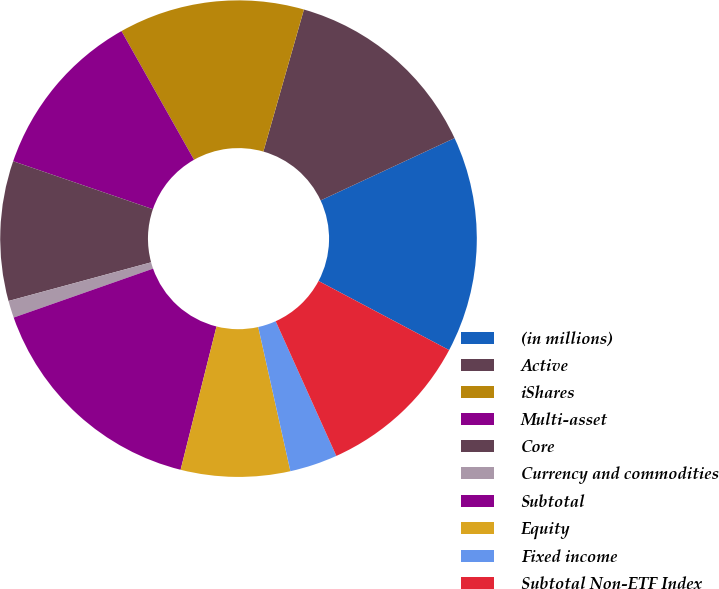Convert chart. <chart><loc_0><loc_0><loc_500><loc_500><pie_chart><fcel>(in millions)<fcel>Active<fcel>iShares<fcel>Multi-asset<fcel>Core<fcel>Currency and commodities<fcel>Subtotal<fcel>Equity<fcel>Fixed income<fcel>Subtotal Non-ETF Index<nl><fcel>14.68%<fcel>13.64%<fcel>12.6%<fcel>11.56%<fcel>9.48%<fcel>1.16%<fcel>15.72%<fcel>7.4%<fcel>3.24%<fcel>10.52%<nl></chart> 